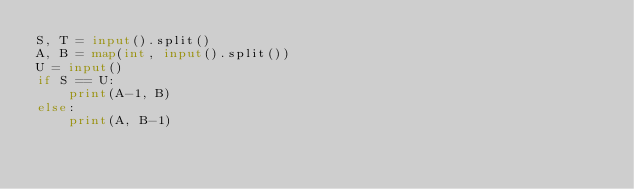<code> <loc_0><loc_0><loc_500><loc_500><_Python_>S, T = input().split()
A, B = map(int, input().split())
U = input()
if S == U:
    print(A-1, B)
else:
    print(A, B-1)</code> 